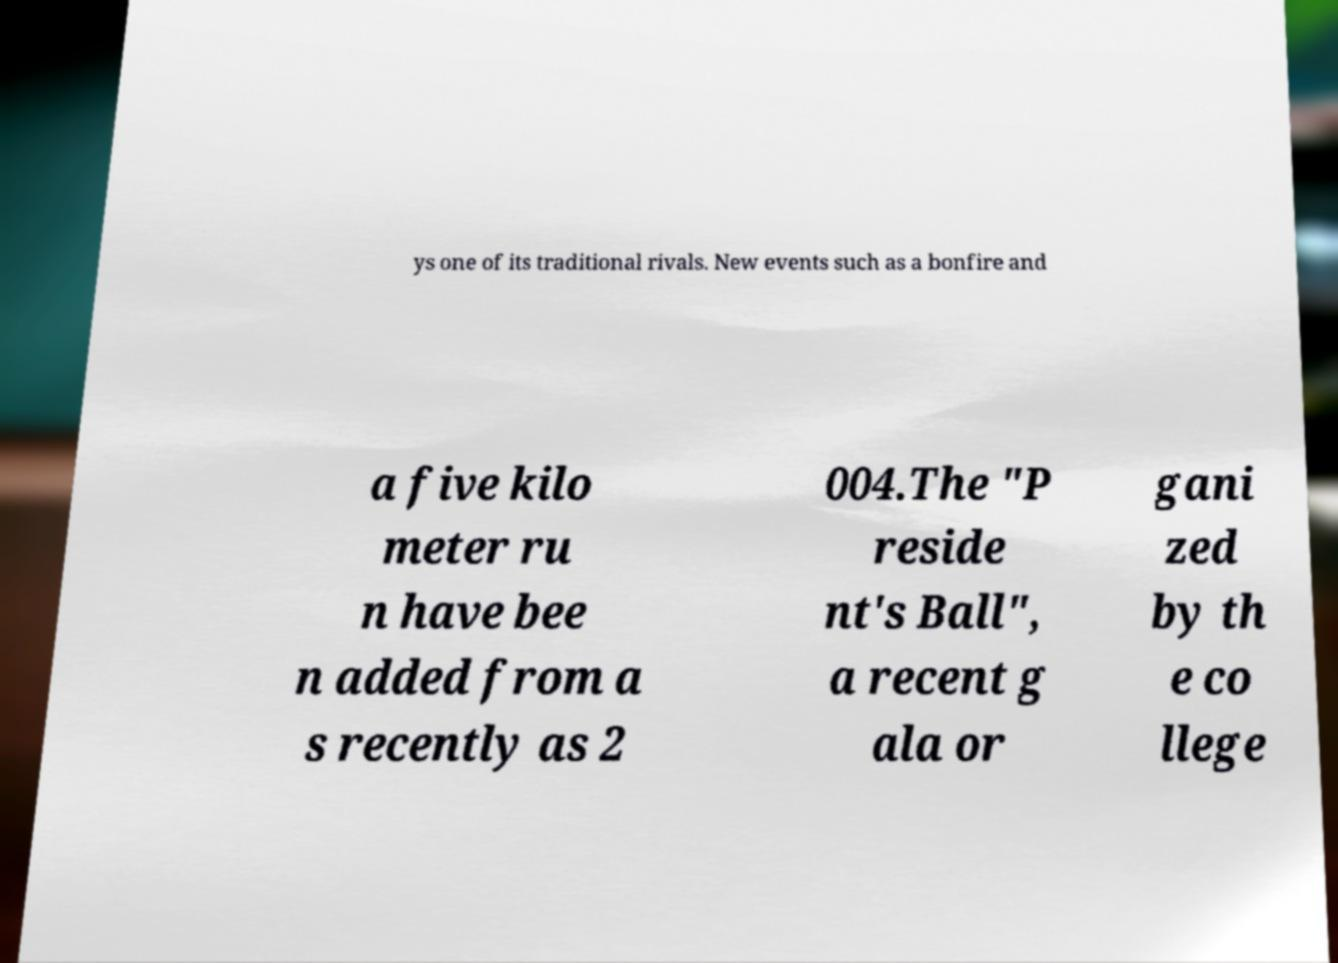Can you read and provide the text displayed in the image?This photo seems to have some interesting text. Can you extract and type it out for me? ys one of its traditional rivals. New events such as a bonfire and a five kilo meter ru n have bee n added from a s recently as 2 004.The "P reside nt's Ball", a recent g ala or gani zed by th e co llege 